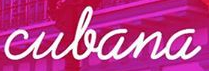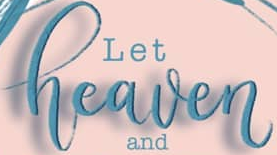Read the text content from these images in order, separated by a semicolon. culana; heaven 